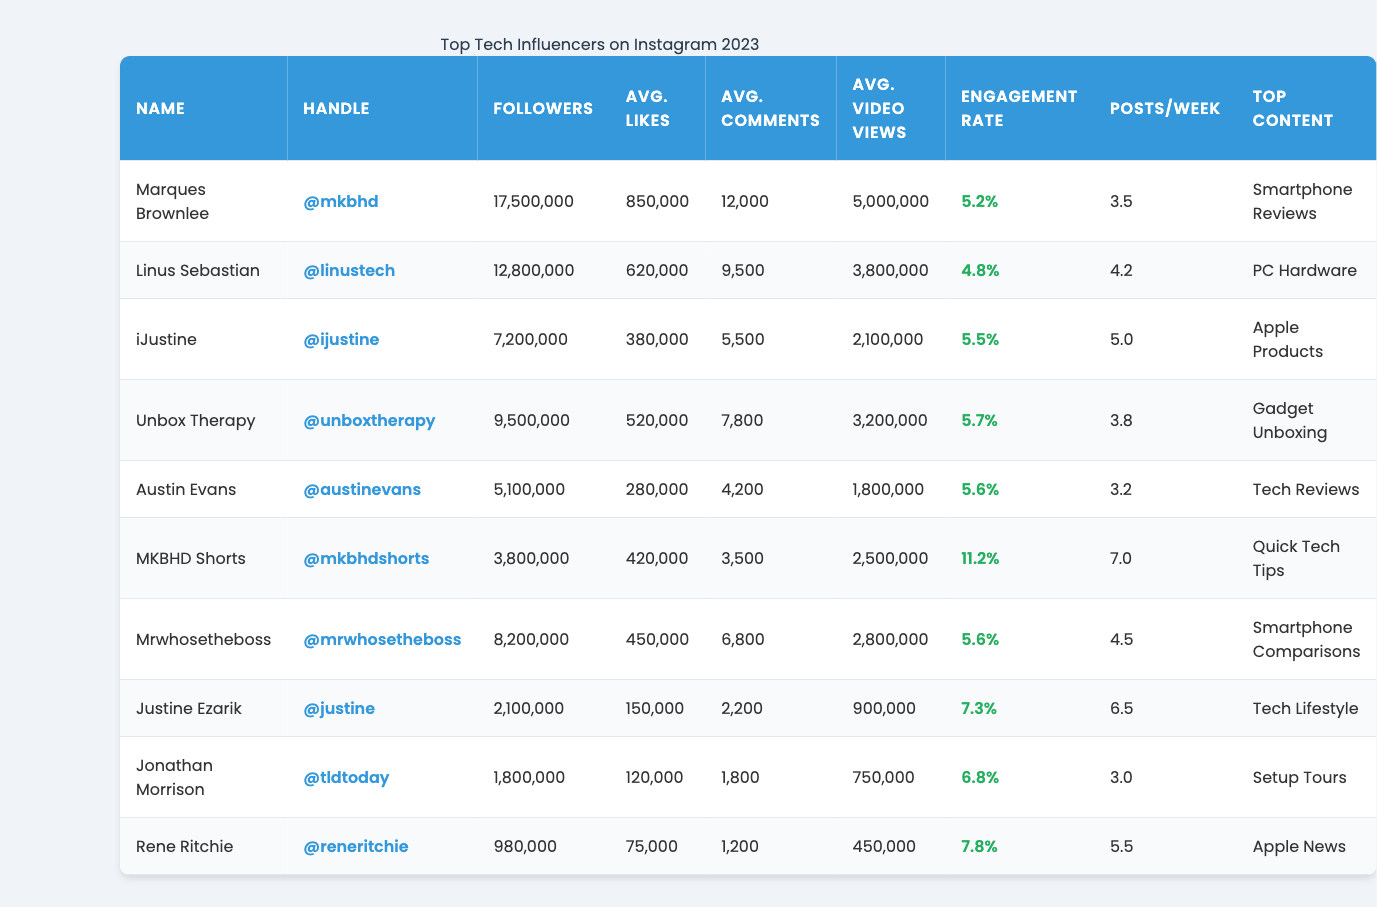What is the engagement rate of Marques Brownlee? The engagement rate of Marques Brownlee, as listed in the table, is 5.2%.
Answer: 5.2% Which influencer has the highest average video views? Analyzing the 'Avg. Video Views' column, Marques Brownlee has 5,000,000 views, which is the highest among the influencers.
Answer: Marques Brownlee What is the total number of followers for the influencers listed in the table? To find the total followers, sum the followers for each influencer: 17,500,000 (Marques) + 12,800,000 (Linus) + 7,200,000 (iJustine) + 9,500,000 (Unbox Therapy) + 5,100,000 (Austin) + 3,800,000 (MKBHD Shorts) + 8,200,000 (Mrwhosetheboss) + 2,100,000 (Justine) + 1,800,000 (Jonathan) + 980,000 (Rene) = 69,980,000.
Answer: 69,980,000 Who posts the most frequently among the influencers? The 'Posts/Week' column shows that MKBHD Shorts posts 7 times a week, which is the highest frequency.
Answer: MKBHD Shorts Is Unbox Therapy's engagement rate higher than Austin Evans'? Unbox Therapy has an engagement rate of 5.7% while Austin Evans has 5.6%. Since 5.7% is greater than 5.6%, it is true that Unbox Therapy's engagement rate is higher.
Answer: Yes What is the average engagement rate of all influencers listed? To find the average engagement rate, sum the engagement rates (5.2 + 4.8 + 5.5 + 5.7 + 5.6 + 11.2 + 5.6 + 7.3 + 6.8 + 7.8) and divide by the number of influencers (10): Total = 66.5% / 10 = 6.65%.
Answer: 6.65% Which influencer has the lowest average likes and how many are they? Looking at the 'Avg. Likes' column, Rene Ritchie has the lowest average likes at 75,000.
Answer: Rene Ritchie, 75,000 If we compare iJustine and Mrwhosetheboss, who has more followers? iJustine has 7,200,000 followers and Mrwhosetheboss has 8,200,000. Since 8,200,000 is greater than 7,200,000, Mrwhosetheboss has more followers.
Answer: Mrwhosetheboss What percentage of posts does Marques Brownlee achieve in average comments compared to his average likes? Calculate the percentage: (Avg. Comments / Avg. Likes) * 100 = (12,000 / 850,000) * 100 = 1.41%.
Answer: 1.41% Can you identify the influencer with the top content category 'Apple Products'? The influencer with the top content category 'Apple Products' is iJustine.
Answer: iJustine 